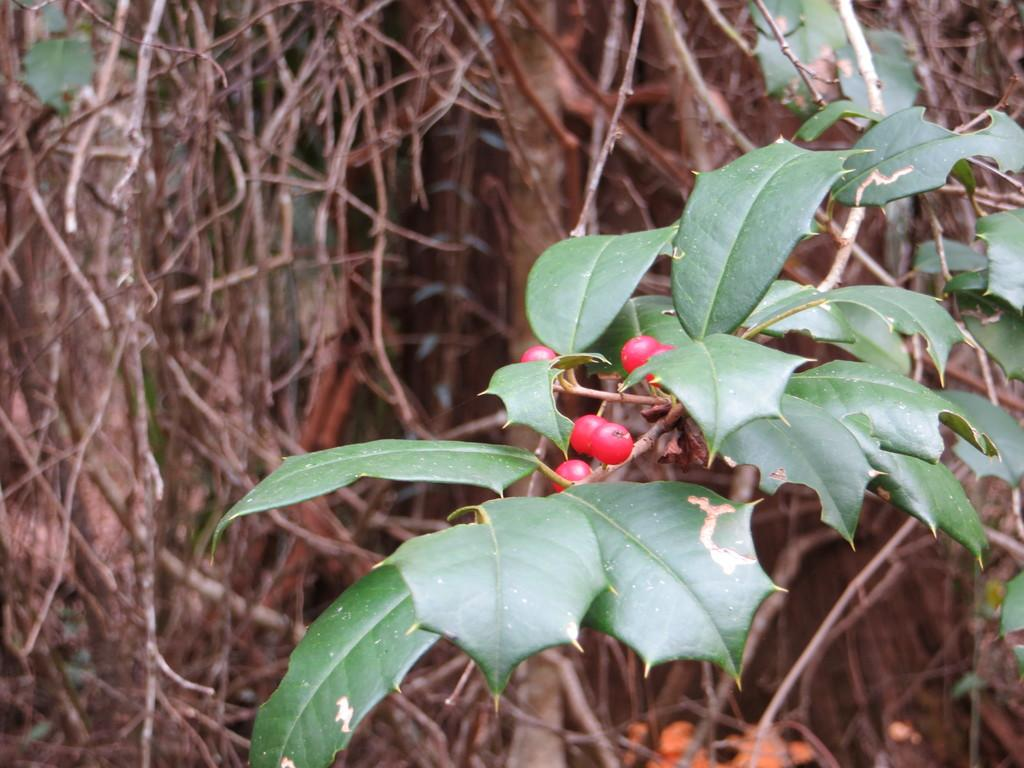What can be seen in the foreground of the image? There are leaves and fruits on a stem in the foreground of the image. What is visible in the background of the image? There is a tree in the background of the image. How is the background of the image depicted? The background is blurred. What type of vest is hanging on the tree in the image? There is no vest present in the image; it features leaves and fruits on a stem in the foreground and a tree in the background. Can you hear the drum being played in the image? There is no drum or sound present in the image; it is a still photograph. 